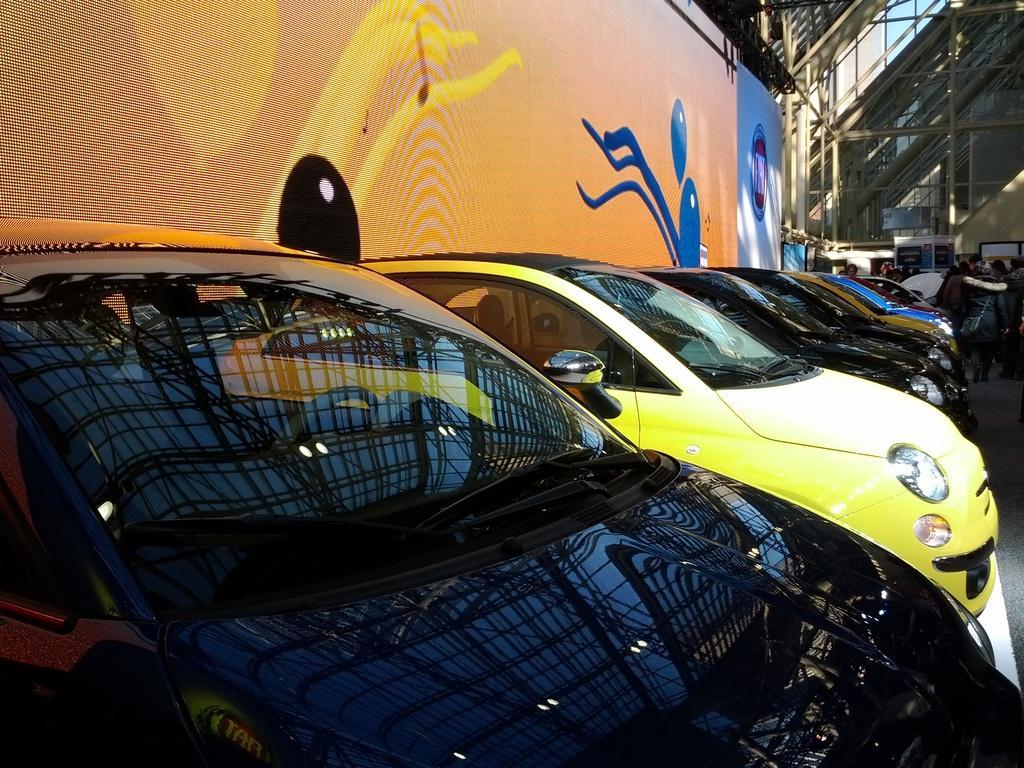Could you give a brief overview of what you see in this image? In the picture I can see these cars are parked on the side. In the background, we can see the banner which is in orange and blue color, we can see stairs and some objects. 